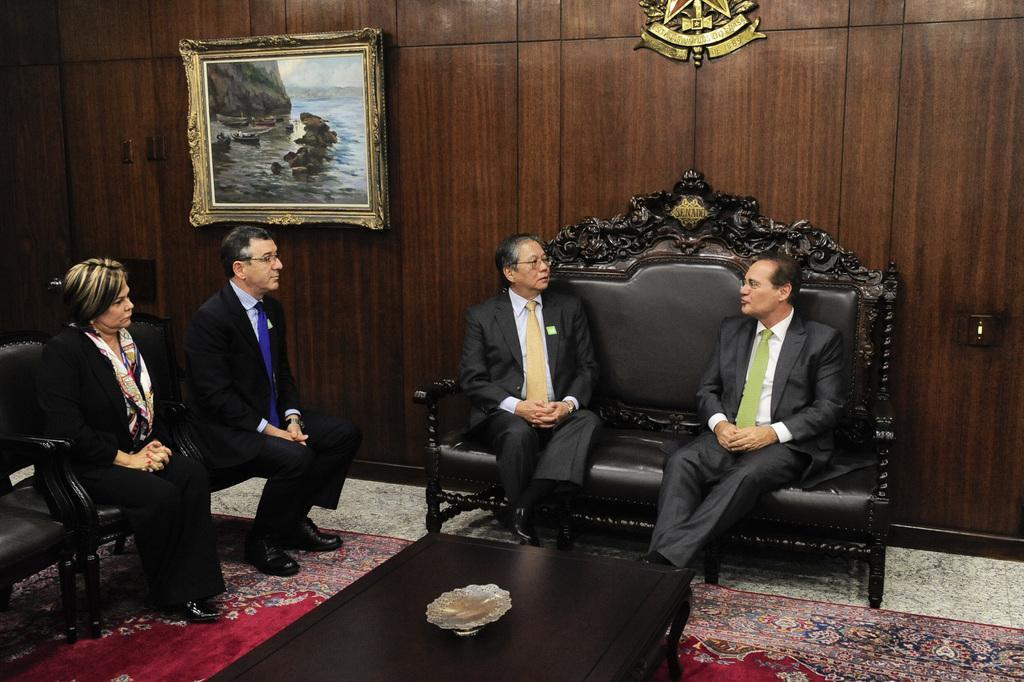Could you give a brief overview of what you see in this image? In the middle of the picture, two men sitting on sofa are talking to each other and in front of them we see a brown table and beside that, we see man in black blazer and woman in black dress sitting on chair are looking those two men sitting on sofa. Behind them, we see a cupboard in brown color and on the cupboard, we see a photo frame. 